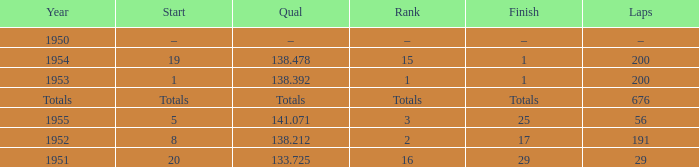How many laps was qualifier of 138.212? 191.0. I'm looking to parse the entire table for insights. Could you assist me with that? {'header': ['Year', 'Start', 'Qual', 'Rank', 'Finish', 'Laps'], 'rows': [['1950', '–', '–', '–', '–', '–'], ['1954', '19', '138.478', '15', '1', '200'], ['1953', '1', '138.392', '1', '1', '200'], ['Totals', 'Totals', 'Totals', 'Totals', 'Totals', '676'], ['1955', '5', '141.071', '3', '25', '56'], ['1952', '8', '138.212', '2', '17', '191'], ['1951', '20', '133.725', '16', '29', '29']]} 